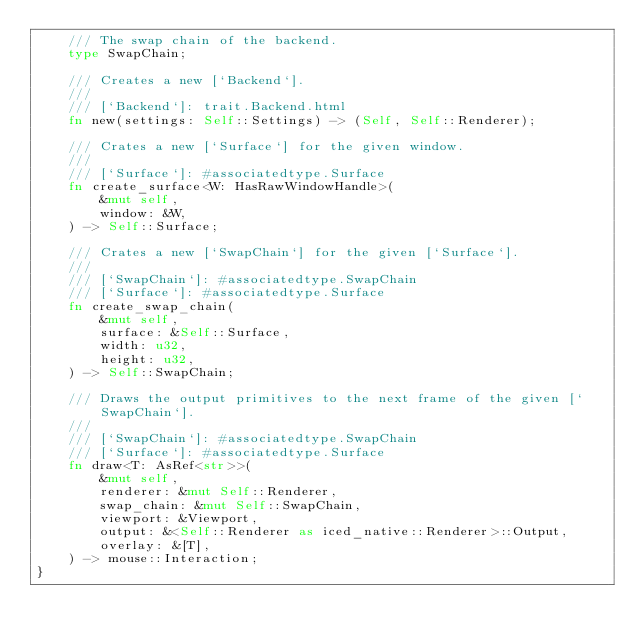Convert code to text. <code><loc_0><loc_0><loc_500><loc_500><_Rust_>    /// The swap chain of the backend.
    type SwapChain;

    /// Creates a new [`Backend`].
    ///
    /// [`Backend`]: trait.Backend.html
    fn new(settings: Self::Settings) -> (Self, Self::Renderer);

    /// Crates a new [`Surface`] for the given window.
    ///
    /// [`Surface`]: #associatedtype.Surface
    fn create_surface<W: HasRawWindowHandle>(
        &mut self,
        window: &W,
    ) -> Self::Surface;

    /// Crates a new [`SwapChain`] for the given [`Surface`].
    ///
    /// [`SwapChain`]: #associatedtype.SwapChain
    /// [`Surface`]: #associatedtype.Surface
    fn create_swap_chain(
        &mut self,
        surface: &Self::Surface,
        width: u32,
        height: u32,
    ) -> Self::SwapChain;

    /// Draws the output primitives to the next frame of the given [`SwapChain`].
    ///
    /// [`SwapChain`]: #associatedtype.SwapChain
    /// [`Surface`]: #associatedtype.Surface
    fn draw<T: AsRef<str>>(
        &mut self,
        renderer: &mut Self::Renderer,
        swap_chain: &mut Self::SwapChain,
        viewport: &Viewport,
        output: &<Self::Renderer as iced_native::Renderer>::Output,
        overlay: &[T],
    ) -> mouse::Interaction;
}
</code> 